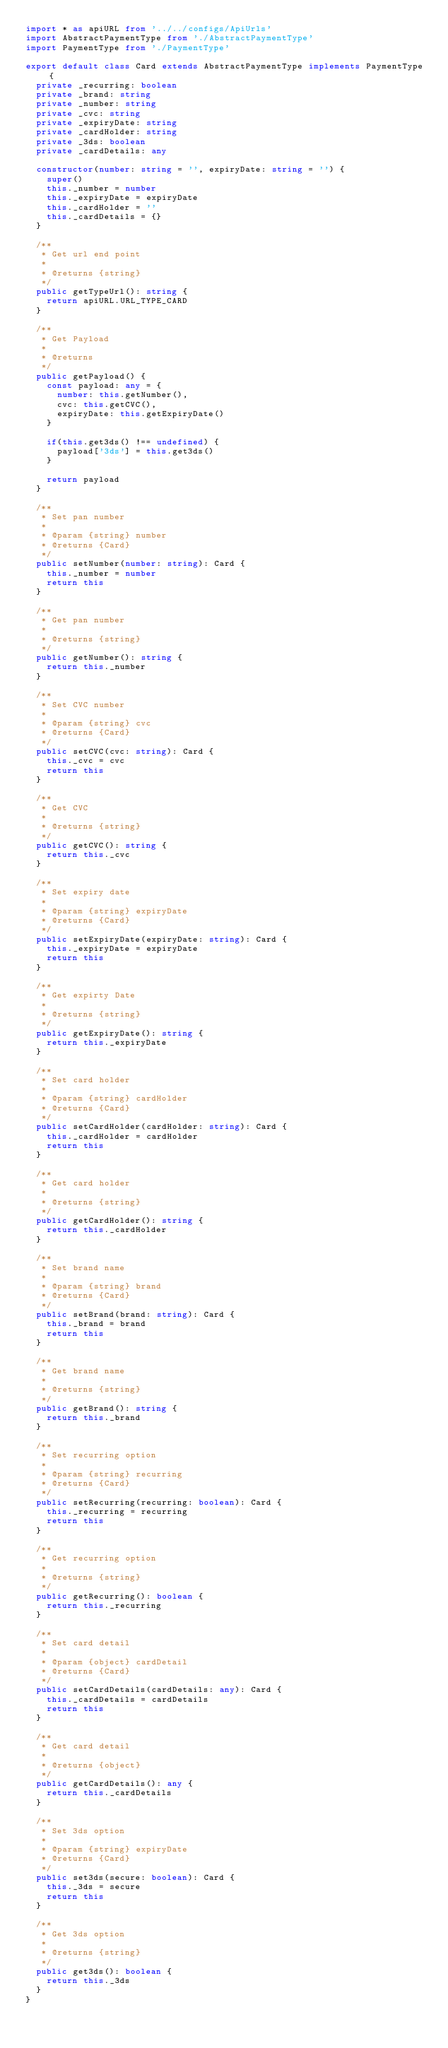<code> <loc_0><loc_0><loc_500><loc_500><_TypeScript_>import * as apiURL from '../../configs/ApiUrls'
import AbstractPaymentType from './AbstractPaymentType'
import PaymentType from './PaymentType'

export default class Card extends AbstractPaymentType implements PaymentType {
  private _recurring: boolean
  private _brand: string
  private _number: string
  private _cvc: string
  private _expiryDate: string
  private _cardHolder: string
  private _3ds: boolean
  private _cardDetails: any

  constructor(number: string = '', expiryDate: string = '') {
    super()
    this._number = number
    this._expiryDate = expiryDate
    this._cardHolder = ''
    this._cardDetails = {}
  }

  /**
   * Get url end point
   *
   * @returns {string}
   */
  public getTypeUrl(): string {
    return apiURL.URL_TYPE_CARD
  }

  /**
   * Get Payload
   *
   * @returns
   */
  public getPayload() {
    const payload: any = {
      number: this.getNumber(),
      cvc: this.getCVC(),
      expiryDate: this.getExpiryDate()
    }

    if(this.get3ds() !== undefined) {
      payload['3ds'] = this.get3ds()
    }

    return payload
  }

  /**
   * Set pan number
   *
   * @param {string} number
   * @returns {Card}
   */
  public setNumber(number: string): Card {
    this._number = number
    return this
  }

  /**
   * Get pan number
   *
   * @returns {string}
   */
  public getNumber(): string {
    return this._number
  }

  /**
   * Set CVC number
   *
   * @param {string} cvc
   * @returns {Card}
   */
  public setCVC(cvc: string): Card {
    this._cvc = cvc
    return this
  }

  /**
   * Get CVC
   *
   * @returns {string}
   */
  public getCVC(): string {
    return this._cvc
  }

  /**
   * Set expiry date
   *
   * @param {string} expiryDate
   * @returns {Card}
   */
  public setExpiryDate(expiryDate: string): Card {
    this._expiryDate = expiryDate
    return this
  }

  /**
   * Get expirty Date
   *
   * @returns {string}
   */
  public getExpiryDate(): string {
    return this._expiryDate
  }

  /**
   * Set card holder
   *
   * @param {string} cardHolder
   * @returns {Card}
   */
  public setCardHolder(cardHolder: string): Card {
    this._cardHolder = cardHolder
    return this
  }

  /**
   * Get card holder
   *
   * @returns {string}
   */
  public getCardHolder(): string {
    return this._cardHolder
  }

  /**
   * Set brand name
   *
   * @param {string} brand
   * @returns {Card}
   */
  public setBrand(brand: string): Card {
    this._brand = brand
    return this
  }

  /**
   * Get brand name
   *
   * @returns {string}
   */
  public getBrand(): string {
    return this._brand
  }

  /**
   * Set recurring option
   *
   * @param {string} recurring
   * @returns {Card}
   */
  public setRecurring(recurring: boolean): Card {
    this._recurring = recurring
    return this
  }

  /**
   * Get recurring option
   *
   * @returns {string}
   */
  public getRecurring(): boolean {
    return this._recurring
  }

  /**
   * Set card detail
   *
   * @param {object} cardDetail
   * @returns {Card}
   */
  public setCardDetails(cardDetails: any): Card {
    this._cardDetails = cardDetails
    return this
  }

  /**
   * Get card detail
   *
   * @returns {object}
   */
  public getCardDetails(): any {
    return this._cardDetails
  }

  /**
   * Set 3ds option
   *
   * @param {string} expiryDate
   * @returns {Card}
   */
  public set3ds(secure: boolean): Card {
    this._3ds = secure
    return this
  }

  /**
   * Get 3ds option
   *
   * @returns {string}
   */
  public get3ds(): boolean {
    return this._3ds
  }
}
</code> 